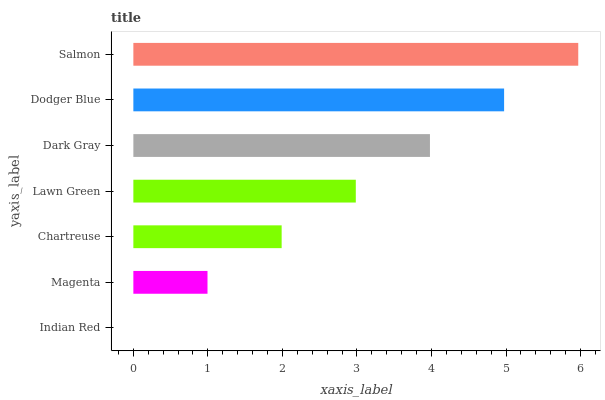Is Indian Red the minimum?
Answer yes or no. Yes. Is Salmon the maximum?
Answer yes or no. Yes. Is Magenta the minimum?
Answer yes or no. No. Is Magenta the maximum?
Answer yes or no. No. Is Magenta greater than Indian Red?
Answer yes or no. Yes. Is Indian Red less than Magenta?
Answer yes or no. Yes. Is Indian Red greater than Magenta?
Answer yes or no. No. Is Magenta less than Indian Red?
Answer yes or no. No. Is Lawn Green the high median?
Answer yes or no. Yes. Is Lawn Green the low median?
Answer yes or no. Yes. Is Salmon the high median?
Answer yes or no. No. Is Dodger Blue the low median?
Answer yes or no. No. 